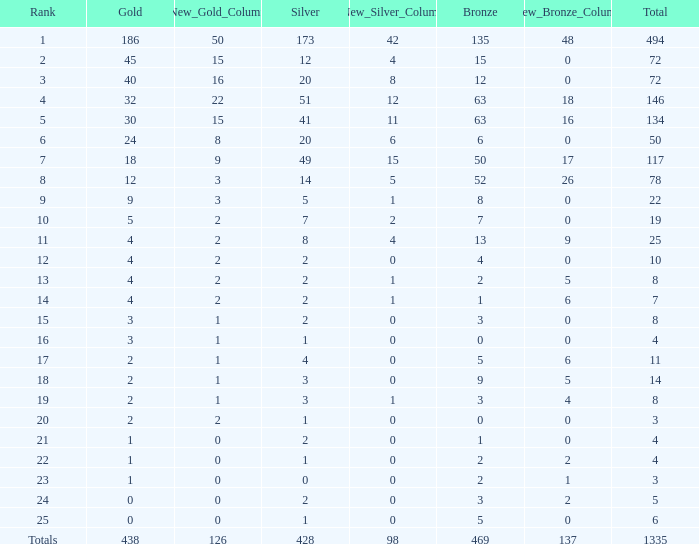What is the total amount of gold medals when there were more than 20 silvers and there were 135 bronze medals? 1.0. 